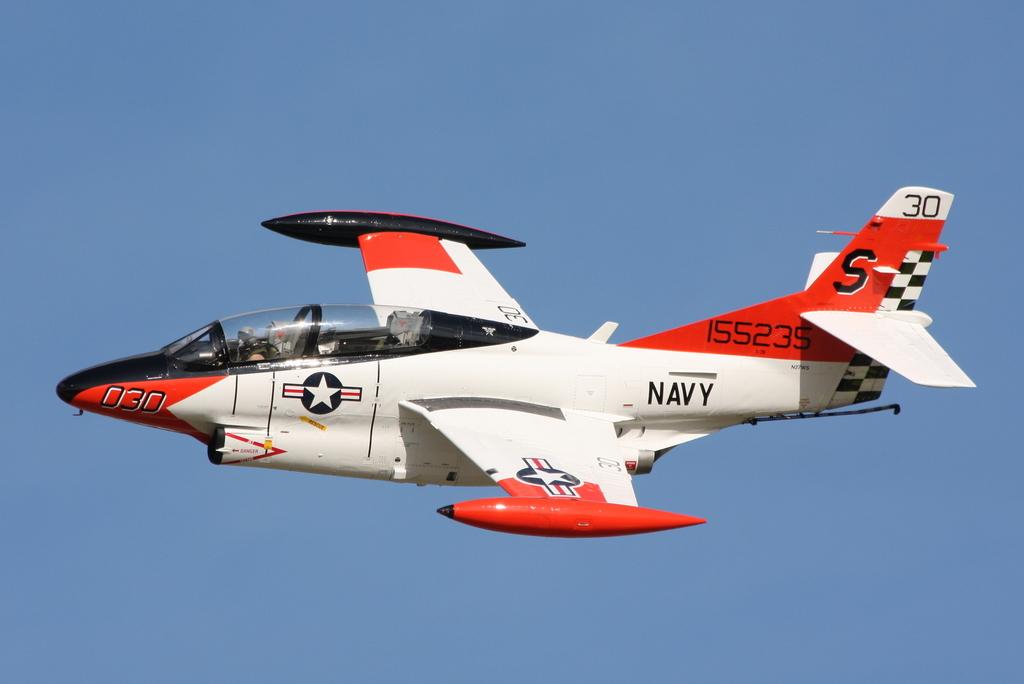Who does this jet belong to?
Your answer should be very brief. Navy. This jet airways?
Your response must be concise. Not a question. 